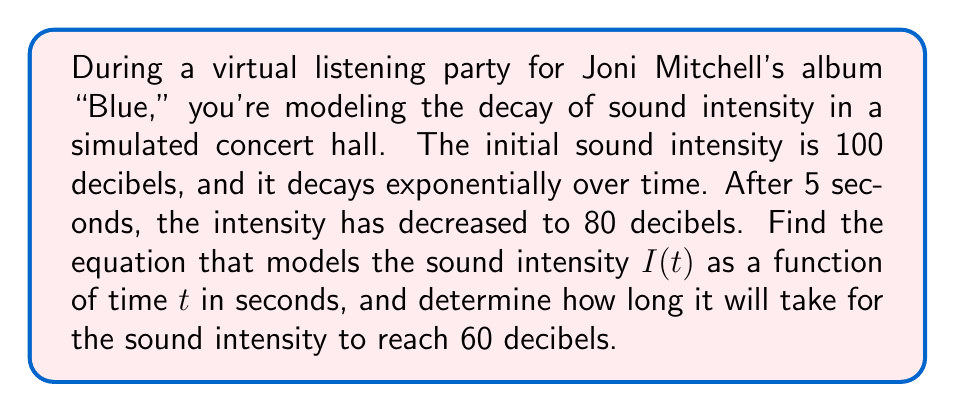Solve this math problem. Let's approach this step-by-step:

1) The general form of an exponential decay function is:

   $I(t) = I_0 e^{-kt}$

   where $I_0$ is the initial intensity, $k$ is the decay constant, and $t$ is time.

2) We know that:
   - $I_0 = 100$ decibels
   - When $t = 5$ seconds, $I = 80$ decibels

3) Let's substitute these values into our equation:

   $80 = 100 e^{-5k}$

4) Divide both sides by 100:

   $0.8 = e^{-5k}$

5) Take the natural log of both sides:

   $\ln(0.8) = -5k$

6) Solve for $k$:

   $k = -\frac{\ln(0.8)}{5} \approx 0.0446$

7) Now we have our complete equation:

   $I(t) = 100 e^{-0.0446t}$

8) To find when the intensity reaches 60 decibels, we set up the equation:

   $60 = 100 e^{-0.0446t}$

9) Divide both sides by 100:

   $0.6 = e^{-0.0446t}$

10) Take the natural log of both sides:

    $\ln(0.6) = -0.0446t$

11) Solve for $t$:

    $t = -\frac{\ln(0.6)}{0.0446} \approx 11.39$ seconds
Answer: The equation modeling sound intensity is $I(t) = 100 e^{-0.0446t}$, where $I$ is in decibels and $t$ is in seconds. It will take approximately 11.39 seconds for the sound intensity to reach 60 decibels. 